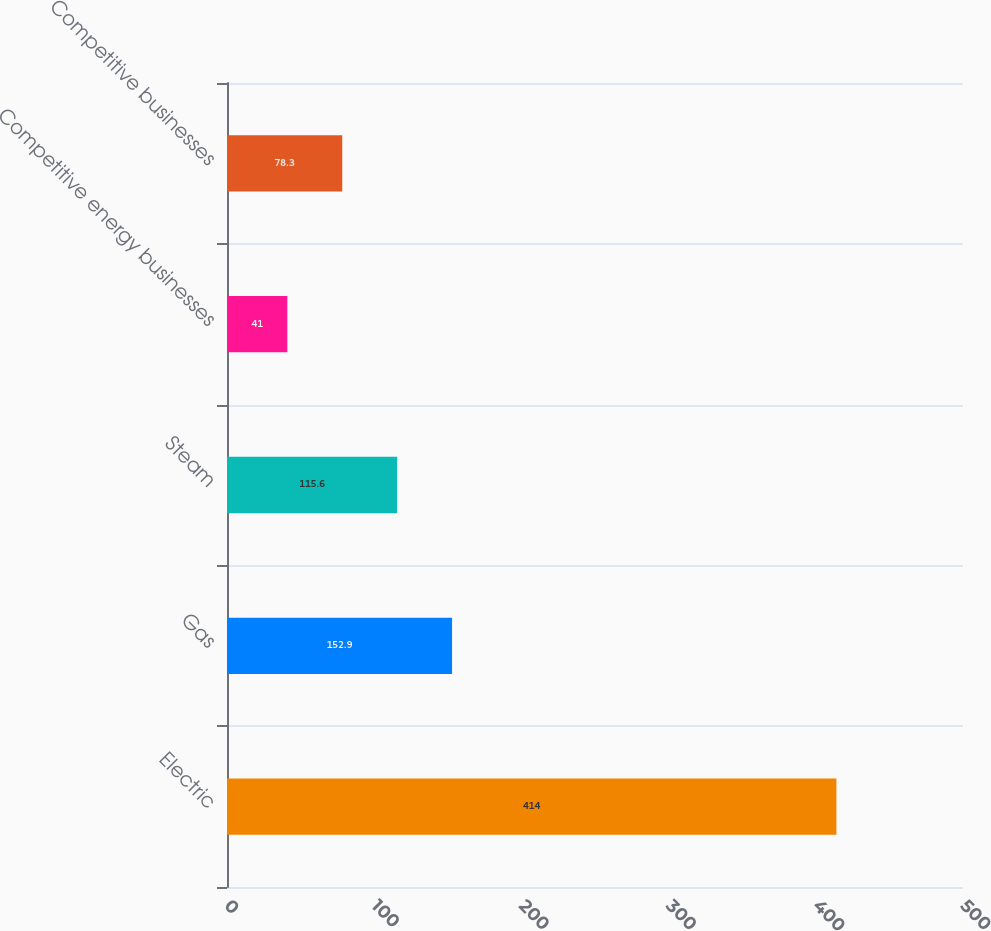Convert chart to OTSL. <chart><loc_0><loc_0><loc_500><loc_500><bar_chart><fcel>Electric<fcel>Gas<fcel>Steam<fcel>Competitive energy businesses<fcel>Competitive businesses<nl><fcel>414<fcel>152.9<fcel>115.6<fcel>41<fcel>78.3<nl></chart> 